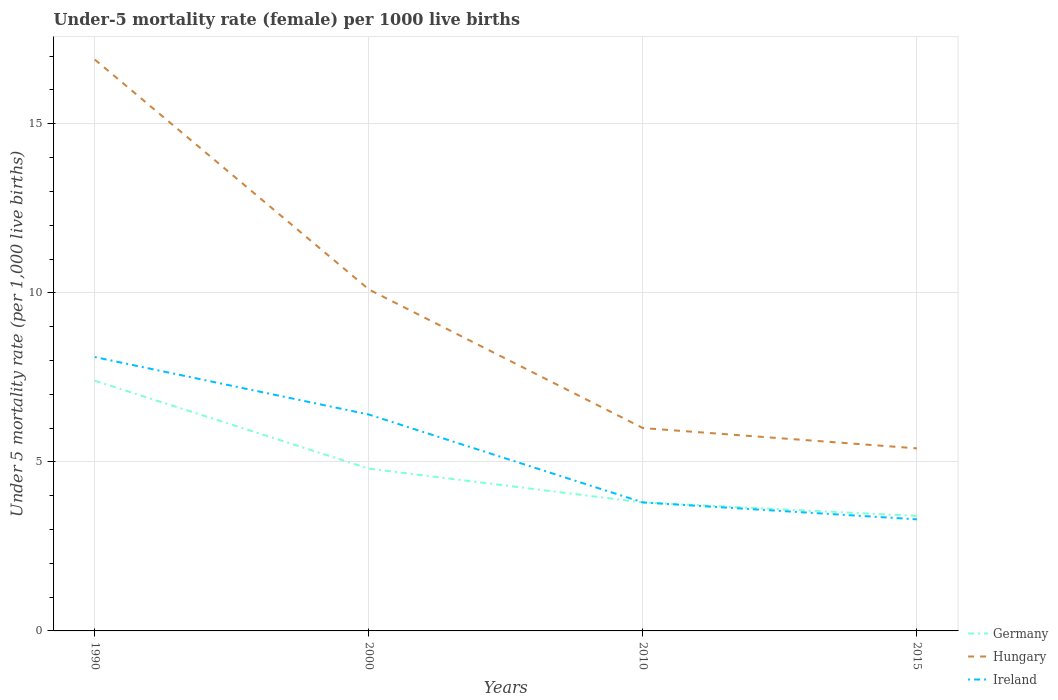Does the line corresponding to Germany intersect with the line corresponding to Hungary?
Keep it short and to the point. No. In which year was the under-five mortality rate in Hungary maximum?
Offer a terse response. 2015. What is the total under-five mortality rate in Hungary in the graph?
Offer a terse response. 6.8. What is the difference between the highest and the second highest under-five mortality rate in Hungary?
Provide a succinct answer. 11.5. Is the under-five mortality rate in Ireland strictly greater than the under-five mortality rate in Germany over the years?
Offer a very short reply. No. How many lines are there?
Offer a terse response. 3. Are the values on the major ticks of Y-axis written in scientific E-notation?
Make the answer very short. No. Does the graph contain any zero values?
Give a very brief answer. No. Does the graph contain grids?
Your answer should be very brief. Yes. How are the legend labels stacked?
Give a very brief answer. Vertical. What is the title of the graph?
Your answer should be compact. Under-5 mortality rate (female) per 1000 live births. What is the label or title of the Y-axis?
Give a very brief answer. Under 5 mortality rate (per 1,0 live births). What is the Under 5 mortality rate (per 1,000 live births) in Germany in 2000?
Provide a short and direct response. 4.8. What is the Under 5 mortality rate (per 1,000 live births) in Hungary in 2000?
Keep it short and to the point. 10.1. What is the Under 5 mortality rate (per 1,000 live births) in Ireland in 2000?
Your answer should be very brief. 6.4. What is the Under 5 mortality rate (per 1,000 live births) in Ireland in 2010?
Give a very brief answer. 3.8. What is the Under 5 mortality rate (per 1,000 live births) of Germany in 2015?
Make the answer very short. 3.4. What is the Under 5 mortality rate (per 1,000 live births) in Hungary in 2015?
Offer a terse response. 5.4. Across all years, what is the maximum Under 5 mortality rate (per 1,000 live births) in Hungary?
Offer a very short reply. 16.9. Across all years, what is the minimum Under 5 mortality rate (per 1,000 live births) in Germany?
Offer a very short reply. 3.4. What is the total Under 5 mortality rate (per 1,000 live births) of Germany in the graph?
Provide a succinct answer. 19.4. What is the total Under 5 mortality rate (per 1,000 live births) of Hungary in the graph?
Provide a succinct answer. 38.4. What is the total Under 5 mortality rate (per 1,000 live births) in Ireland in the graph?
Give a very brief answer. 21.6. What is the difference between the Under 5 mortality rate (per 1,000 live births) of Germany in 1990 and that in 2000?
Keep it short and to the point. 2.6. What is the difference between the Under 5 mortality rate (per 1,000 live births) in Ireland in 1990 and that in 2000?
Provide a succinct answer. 1.7. What is the difference between the Under 5 mortality rate (per 1,000 live births) in Hungary in 1990 and that in 2010?
Keep it short and to the point. 10.9. What is the difference between the Under 5 mortality rate (per 1,000 live births) of Hungary in 1990 and that in 2015?
Ensure brevity in your answer.  11.5. What is the difference between the Under 5 mortality rate (per 1,000 live births) of Germany in 2000 and that in 2010?
Ensure brevity in your answer.  1. What is the difference between the Under 5 mortality rate (per 1,000 live births) of Germany in 2000 and that in 2015?
Provide a succinct answer. 1.4. What is the difference between the Under 5 mortality rate (per 1,000 live births) in Hungary in 2000 and that in 2015?
Provide a short and direct response. 4.7. What is the difference between the Under 5 mortality rate (per 1,000 live births) of Ireland in 2000 and that in 2015?
Make the answer very short. 3.1. What is the difference between the Under 5 mortality rate (per 1,000 live births) of Hungary in 2010 and that in 2015?
Your answer should be compact. 0.6. What is the difference between the Under 5 mortality rate (per 1,000 live births) in Ireland in 2010 and that in 2015?
Your response must be concise. 0.5. What is the difference between the Under 5 mortality rate (per 1,000 live births) in Hungary in 1990 and the Under 5 mortality rate (per 1,000 live births) in Ireland in 2000?
Your answer should be compact. 10.5. What is the difference between the Under 5 mortality rate (per 1,000 live births) of Germany in 1990 and the Under 5 mortality rate (per 1,000 live births) of Hungary in 2010?
Make the answer very short. 1.4. What is the difference between the Under 5 mortality rate (per 1,000 live births) of Germany in 1990 and the Under 5 mortality rate (per 1,000 live births) of Ireland in 2010?
Offer a very short reply. 3.6. What is the difference between the Under 5 mortality rate (per 1,000 live births) in Germany in 1990 and the Under 5 mortality rate (per 1,000 live births) in Ireland in 2015?
Offer a very short reply. 4.1. What is the difference between the Under 5 mortality rate (per 1,000 live births) in Hungary in 1990 and the Under 5 mortality rate (per 1,000 live births) in Ireland in 2015?
Your answer should be compact. 13.6. What is the difference between the Under 5 mortality rate (per 1,000 live births) in Hungary in 2000 and the Under 5 mortality rate (per 1,000 live births) in Ireland in 2010?
Provide a succinct answer. 6.3. What is the difference between the Under 5 mortality rate (per 1,000 live births) of Germany in 2010 and the Under 5 mortality rate (per 1,000 live births) of Hungary in 2015?
Your answer should be compact. -1.6. What is the difference between the Under 5 mortality rate (per 1,000 live births) in Hungary in 2010 and the Under 5 mortality rate (per 1,000 live births) in Ireland in 2015?
Your response must be concise. 2.7. What is the average Under 5 mortality rate (per 1,000 live births) in Germany per year?
Keep it short and to the point. 4.85. What is the average Under 5 mortality rate (per 1,000 live births) in Hungary per year?
Offer a terse response. 9.6. In the year 1990, what is the difference between the Under 5 mortality rate (per 1,000 live births) in Germany and Under 5 mortality rate (per 1,000 live births) in Hungary?
Offer a very short reply. -9.5. In the year 1990, what is the difference between the Under 5 mortality rate (per 1,000 live births) in Germany and Under 5 mortality rate (per 1,000 live births) in Ireland?
Offer a very short reply. -0.7. In the year 1990, what is the difference between the Under 5 mortality rate (per 1,000 live births) of Hungary and Under 5 mortality rate (per 1,000 live births) of Ireland?
Offer a very short reply. 8.8. In the year 2000, what is the difference between the Under 5 mortality rate (per 1,000 live births) in Germany and Under 5 mortality rate (per 1,000 live births) in Hungary?
Ensure brevity in your answer.  -5.3. In the year 2000, what is the difference between the Under 5 mortality rate (per 1,000 live births) of Germany and Under 5 mortality rate (per 1,000 live births) of Ireland?
Keep it short and to the point. -1.6. In the year 2010, what is the difference between the Under 5 mortality rate (per 1,000 live births) of Germany and Under 5 mortality rate (per 1,000 live births) of Hungary?
Your response must be concise. -2.2. In the year 2010, what is the difference between the Under 5 mortality rate (per 1,000 live births) of Hungary and Under 5 mortality rate (per 1,000 live births) of Ireland?
Your answer should be compact. 2.2. What is the ratio of the Under 5 mortality rate (per 1,000 live births) of Germany in 1990 to that in 2000?
Your answer should be very brief. 1.54. What is the ratio of the Under 5 mortality rate (per 1,000 live births) of Hungary in 1990 to that in 2000?
Your response must be concise. 1.67. What is the ratio of the Under 5 mortality rate (per 1,000 live births) in Ireland in 1990 to that in 2000?
Your response must be concise. 1.27. What is the ratio of the Under 5 mortality rate (per 1,000 live births) of Germany in 1990 to that in 2010?
Your answer should be compact. 1.95. What is the ratio of the Under 5 mortality rate (per 1,000 live births) of Hungary in 1990 to that in 2010?
Provide a short and direct response. 2.82. What is the ratio of the Under 5 mortality rate (per 1,000 live births) of Ireland in 1990 to that in 2010?
Make the answer very short. 2.13. What is the ratio of the Under 5 mortality rate (per 1,000 live births) in Germany in 1990 to that in 2015?
Your response must be concise. 2.18. What is the ratio of the Under 5 mortality rate (per 1,000 live births) of Hungary in 1990 to that in 2015?
Your response must be concise. 3.13. What is the ratio of the Under 5 mortality rate (per 1,000 live births) of Ireland in 1990 to that in 2015?
Keep it short and to the point. 2.45. What is the ratio of the Under 5 mortality rate (per 1,000 live births) of Germany in 2000 to that in 2010?
Your answer should be compact. 1.26. What is the ratio of the Under 5 mortality rate (per 1,000 live births) in Hungary in 2000 to that in 2010?
Ensure brevity in your answer.  1.68. What is the ratio of the Under 5 mortality rate (per 1,000 live births) of Ireland in 2000 to that in 2010?
Your response must be concise. 1.68. What is the ratio of the Under 5 mortality rate (per 1,000 live births) of Germany in 2000 to that in 2015?
Provide a succinct answer. 1.41. What is the ratio of the Under 5 mortality rate (per 1,000 live births) of Hungary in 2000 to that in 2015?
Provide a succinct answer. 1.87. What is the ratio of the Under 5 mortality rate (per 1,000 live births) in Ireland in 2000 to that in 2015?
Offer a very short reply. 1.94. What is the ratio of the Under 5 mortality rate (per 1,000 live births) of Germany in 2010 to that in 2015?
Give a very brief answer. 1.12. What is the ratio of the Under 5 mortality rate (per 1,000 live births) of Ireland in 2010 to that in 2015?
Your answer should be very brief. 1.15. What is the difference between the highest and the second highest Under 5 mortality rate (per 1,000 live births) in Germany?
Keep it short and to the point. 2.6. What is the difference between the highest and the second highest Under 5 mortality rate (per 1,000 live births) in Hungary?
Provide a succinct answer. 6.8. What is the difference between the highest and the second highest Under 5 mortality rate (per 1,000 live births) of Ireland?
Your response must be concise. 1.7. What is the difference between the highest and the lowest Under 5 mortality rate (per 1,000 live births) of Germany?
Offer a very short reply. 4. 